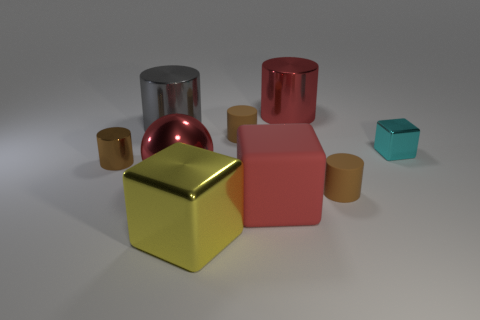How many metallic cylinders are the same color as the big shiny sphere?
Offer a very short reply. 1. What material is the brown object behind the metal block behind the red metallic sphere?
Ensure brevity in your answer.  Rubber. The red metal sphere is what size?
Offer a terse response. Large. What number of metallic balls are the same size as the gray metal cylinder?
Your response must be concise. 1. How many big red shiny objects have the same shape as the large yellow thing?
Keep it short and to the point. 0. Are there the same number of big shiny things that are behind the large matte object and yellow things?
Your answer should be very brief. No. Is there anything else that is the same size as the gray object?
Your answer should be very brief. Yes. There is a matte object that is the same size as the red sphere; what is its shape?
Provide a succinct answer. Cube. Is there a small rubber thing of the same shape as the big yellow thing?
Your answer should be compact. No. Are there any large gray objects to the right of the brown cylinder to the right of the small brown rubber cylinder that is behind the small brown shiny cylinder?
Keep it short and to the point. No. 